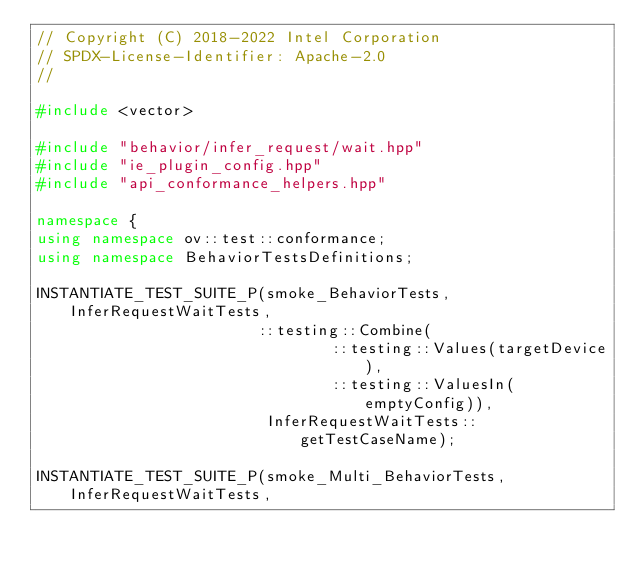Convert code to text. <code><loc_0><loc_0><loc_500><loc_500><_C++_>// Copyright (C) 2018-2022 Intel Corporation
// SPDX-License-Identifier: Apache-2.0
//

#include <vector>

#include "behavior/infer_request/wait.hpp"
#include "ie_plugin_config.hpp"
#include "api_conformance_helpers.hpp"

namespace {
using namespace ov::test::conformance;
using namespace BehaviorTestsDefinitions;

INSTANTIATE_TEST_SUITE_P(smoke_BehaviorTests, InferRequestWaitTests,
                        ::testing::Combine(
                                ::testing::Values(targetDevice),
                                ::testing::ValuesIn(emptyConfig)),
                         InferRequestWaitTests::getTestCaseName);

INSTANTIATE_TEST_SUITE_P(smoke_Multi_BehaviorTests, InferRequestWaitTests,</code> 